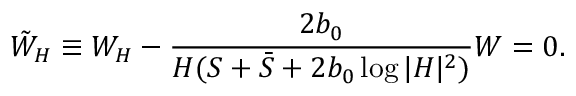<formula> <loc_0><loc_0><loc_500><loc_500>\tilde { W } _ { H } \equiv W _ { H } - \frac { 2 b _ { 0 } } { H ( S + \bar { S } + 2 b _ { 0 } \log | H | ^ { 2 } ) } W = 0 .</formula> 